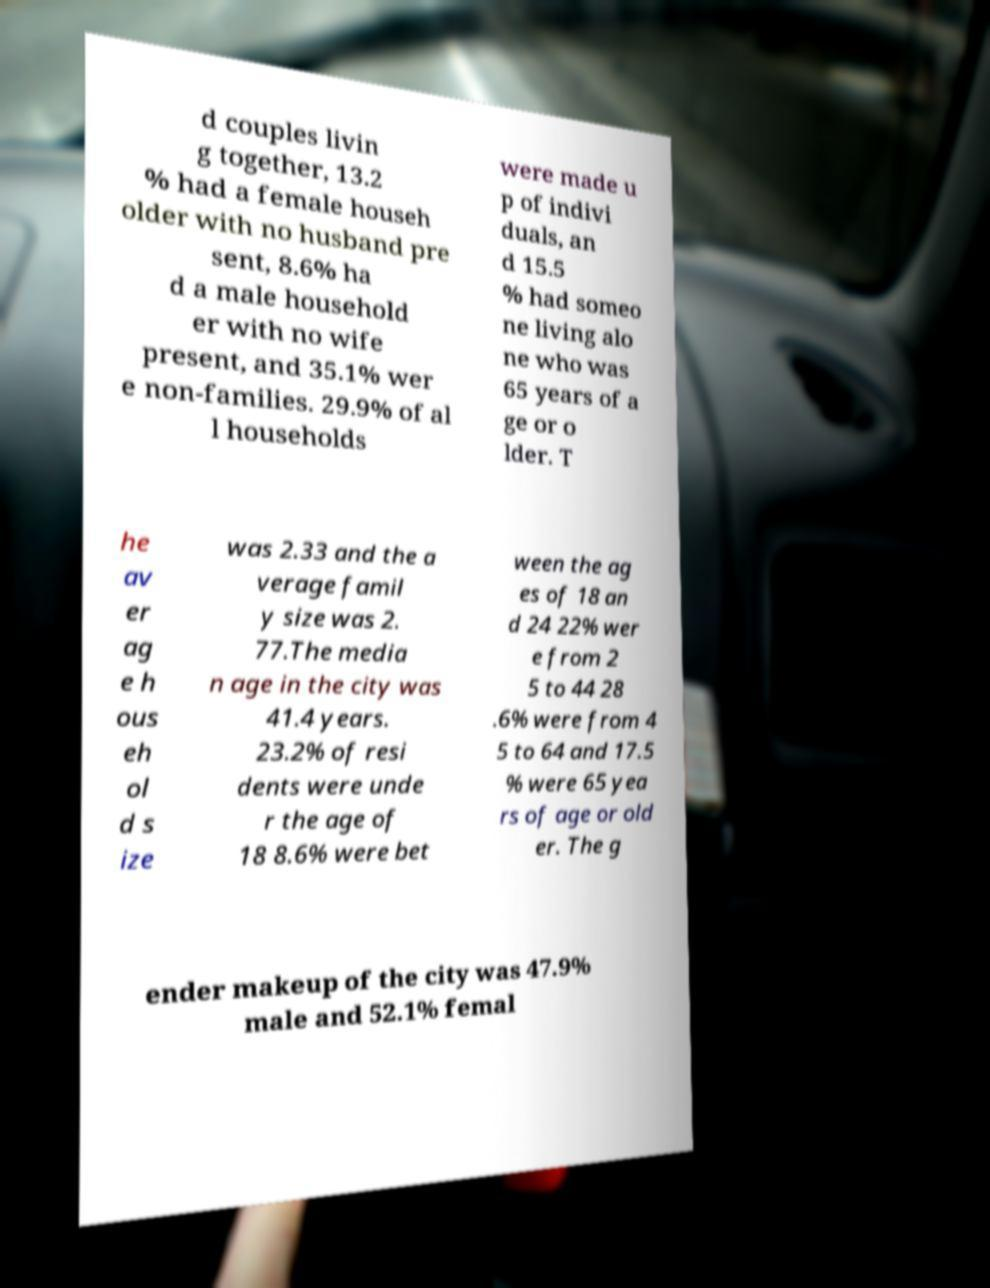What messages or text are displayed in this image? I need them in a readable, typed format. d couples livin g together, 13.2 % had a female househ older with no husband pre sent, 8.6% ha d a male household er with no wife present, and 35.1% wer e non-families. 29.9% of al l households were made u p of indivi duals, an d 15.5 % had someo ne living alo ne who was 65 years of a ge or o lder. T he av er ag e h ous eh ol d s ize was 2.33 and the a verage famil y size was 2. 77.The media n age in the city was 41.4 years. 23.2% of resi dents were unde r the age of 18 8.6% were bet ween the ag es of 18 an d 24 22% wer e from 2 5 to 44 28 .6% were from 4 5 to 64 and 17.5 % were 65 yea rs of age or old er. The g ender makeup of the city was 47.9% male and 52.1% femal 